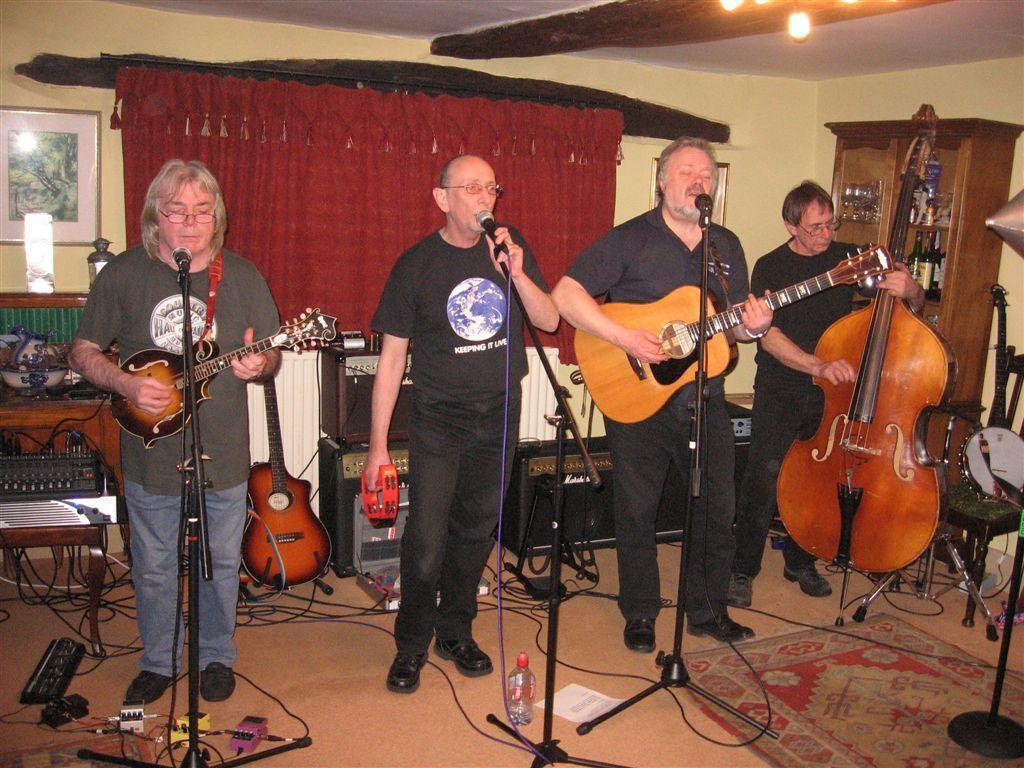In one or two sentences, can you explain what this image depicts? In the image we can see four persons were standing and holding guitar. In front of them we can see microphone. In the background there is a curtain,wall,photo frame,cupboard and few other objects. 